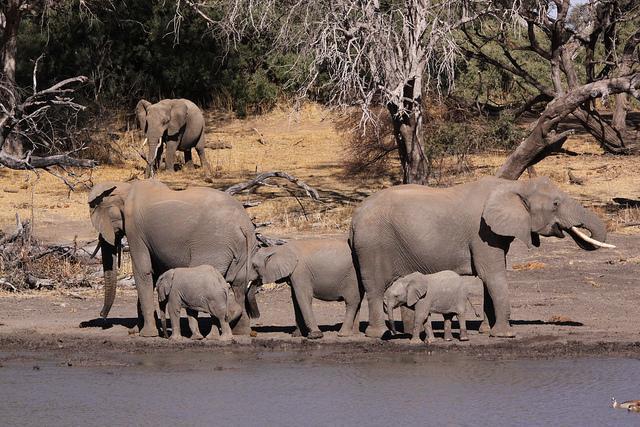How many young elephants are there?
Give a very brief answer. 4. How many elephants are there?
Give a very brief answer. 6. How many different types of animals are there?
Give a very brief answer. 1. How many elephants?
Give a very brief answer. 6. How many animals are there?
Give a very brief answer. 6. How many elephants are seen?
Give a very brief answer. 6. How many elephants can you see?
Give a very brief answer. 6. 